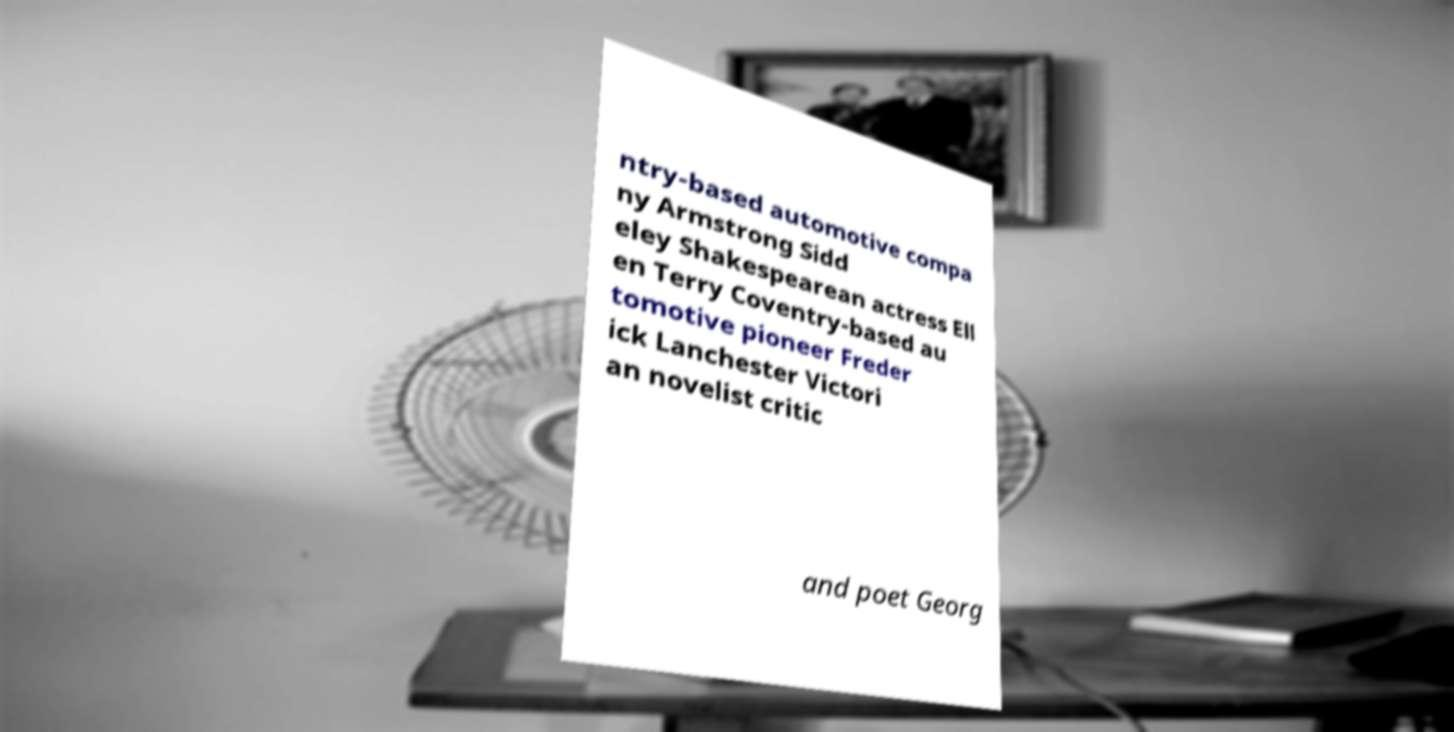What messages or text are displayed in this image? I need them in a readable, typed format. ntry-based automotive compa ny Armstrong Sidd eley Shakespearean actress Ell en Terry Coventry-based au tomotive pioneer Freder ick Lanchester Victori an novelist critic and poet Georg 